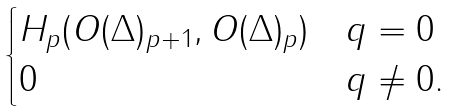<formula> <loc_0><loc_0><loc_500><loc_500>\begin{cases} H _ { p } ( O ( \Delta ) _ { p + 1 } , O ( \Delta ) _ { p } ) & q = 0 \\ 0 & q \neq 0 . \end{cases}</formula> 